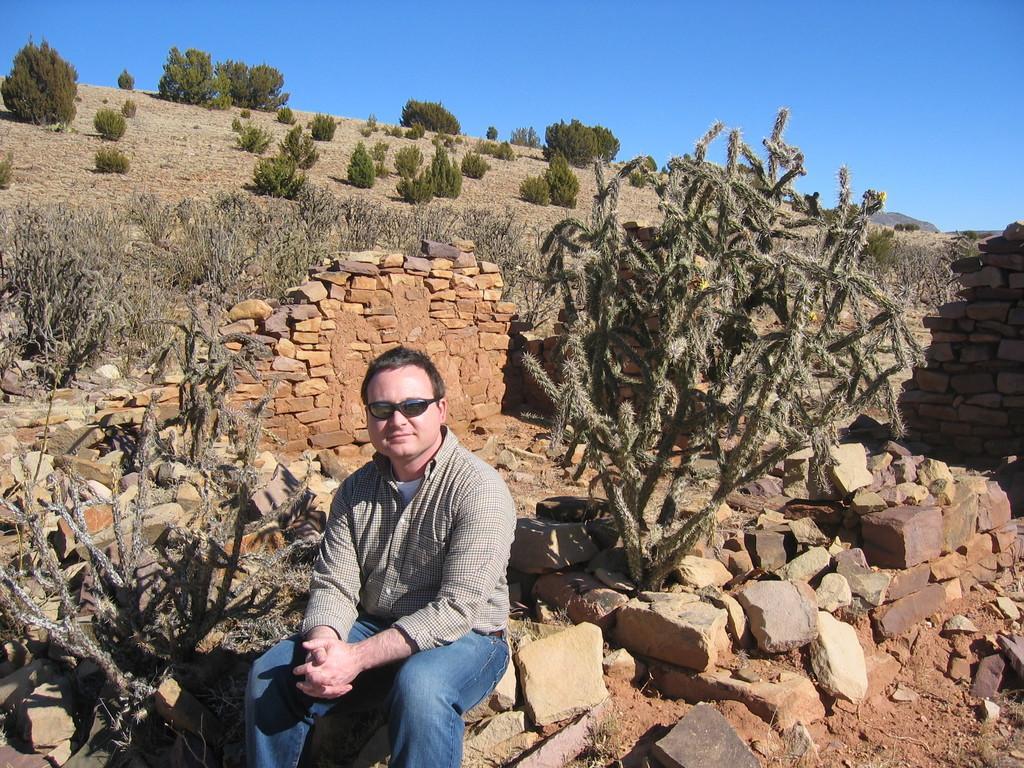In one or two sentences, can you explain what this image depicts? In the foreground I can see a person is sitting on a stone and I can see plants. In the background I can see stones fence, trees, grass and the sky. This image is taken may be during a day. 